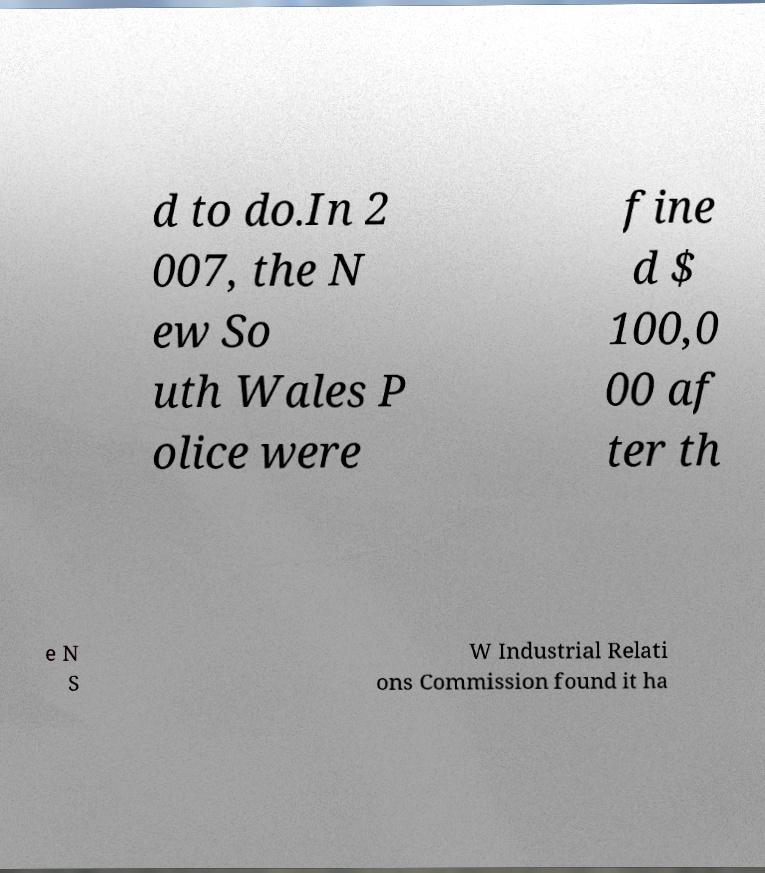I need the written content from this picture converted into text. Can you do that? d to do.In 2 007, the N ew So uth Wales P olice were fine d $ 100,0 00 af ter th e N S W Industrial Relati ons Commission found it ha 